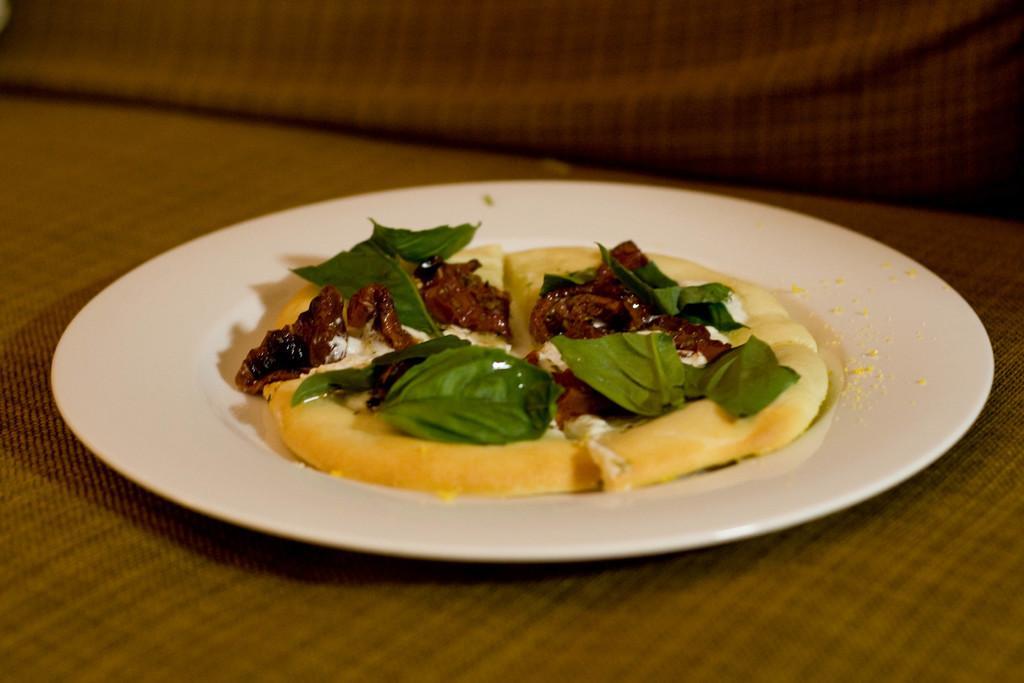In one or two sentences, can you explain what this image depicts? In the image on the brown color surface there is a white pate. In the plate there is a food item and green leaves on it. 